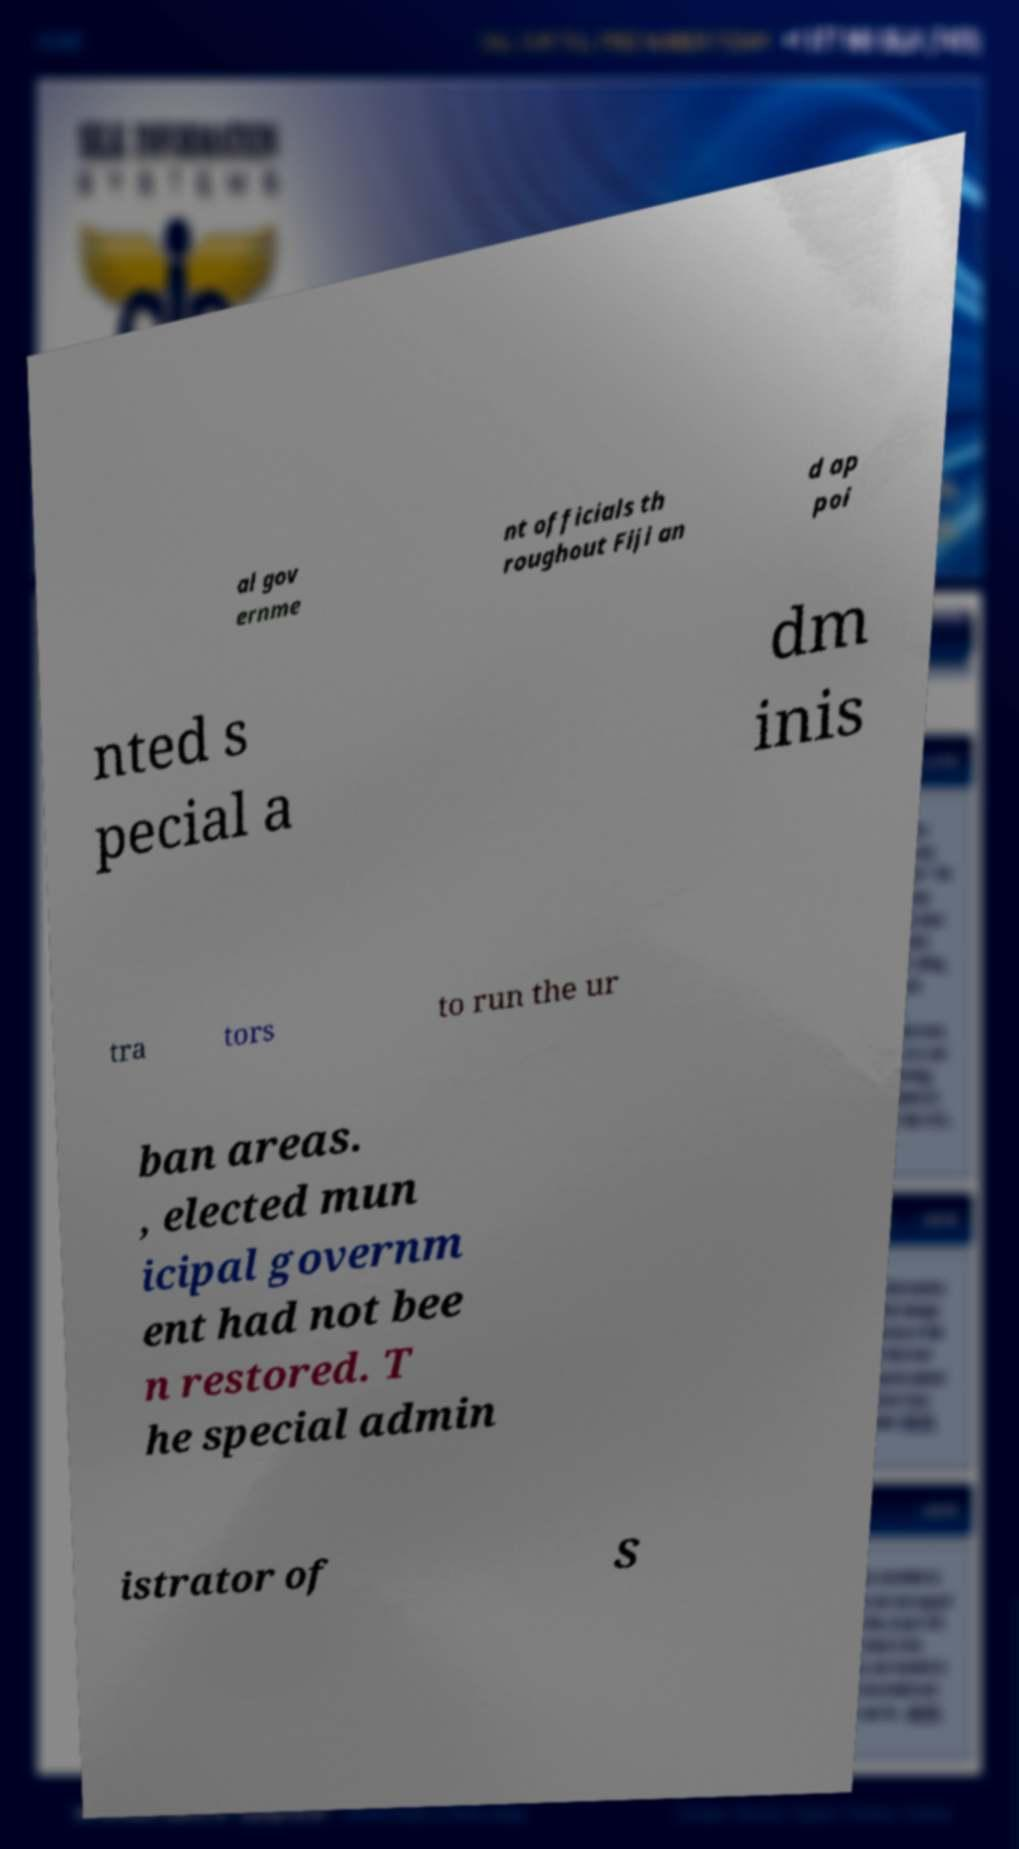What messages or text are displayed in this image? I need them in a readable, typed format. al gov ernme nt officials th roughout Fiji an d ap poi nted s pecial a dm inis tra tors to run the ur ban areas. , elected mun icipal governm ent had not bee n restored. T he special admin istrator of S 